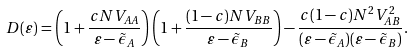Convert formula to latex. <formula><loc_0><loc_0><loc_500><loc_500>D ( \varepsilon ) = \left ( 1 + \frac { c N V _ { A A } } { \varepsilon - \tilde { \epsilon } _ { A } } \right ) \left ( 1 + \frac { ( 1 - c ) N V _ { B B } } { \varepsilon - \tilde { \epsilon } _ { B } } \right ) - \frac { c ( 1 - c ) N ^ { 2 } V _ { A B } ^ { 2 } } { ( \varepsilon - \tilde { \epsilon } _ { A } ) ( \varepsilon - \tilde { \epsilon } _ { B } ) } .</formula> 